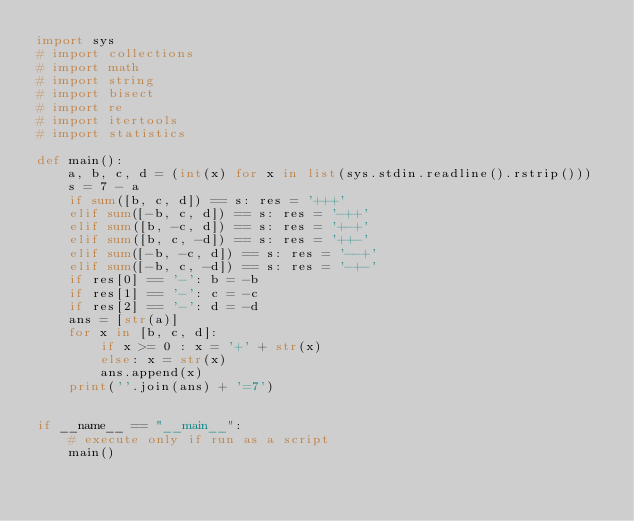<code> <loc_0><loc_0><loc_500><loc_500><_Python_>import sys
# import collections
# import math
# import string
# import bisect
# import re
# import itertools
# import statistics

def main():
    a, b, c, d = (int(x) for x in list(sys.stdin.readline().rstrip()))
    s = 7 - a
    if sum([b, c, d]) == s: res = '+++'
    elif sum([-b, c, d]) == s: res = '-++'
    elif sum([b, -c, d]) == s: res = '+-+'
    elif sum([b, c, -d]) == s: res = '++-'
    elif sum([-b, -c, d]) == s: res = '--+'
    elif sum([-b, c, -d]) == s: res = '-+-' 
    if res[0] == '-': b = -b
    if res[1] == '-': c = -c
    if res[2] == '-': d = -d
    ans = [str(a)]
    for x in [b, c, d]:
        if x >= 0 : x = '+' + str(x)
        else: x = str(x)
        ans.append(x)
    print(''.join(ans) + '=7')


if __name__ == "__main__":
    # execute only if run as a script
    main()
</code> 